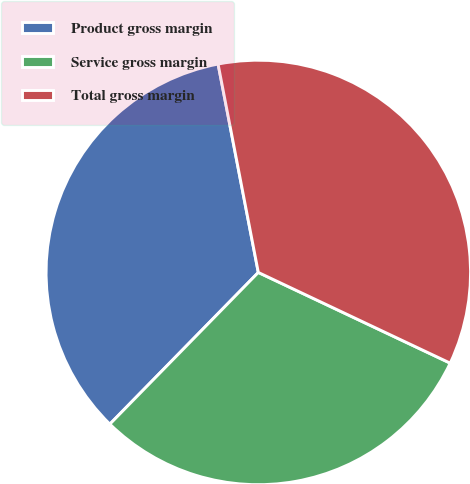Convert chart. <chart><loc_0><loc_0><loc_500><loc_500><pie_chart><fcel>Product gross margin<fcel>Service gross margin<fcel>Total gross margin<nl><fcel>34.63%<fcel>30.3%<fcel>35.06%<nl></chart> 